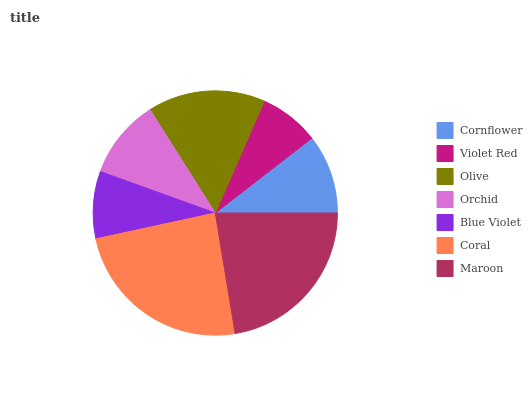Is Violet Red the minimum?
Answer yes or no. Yes. Is Coral the maximum?
Answer yes or no. Yes. Is Olive the minimum?
Answer yes or no. No. Is Olive the maximum?
Answer yes or no. No. Is Olive greater than Violet Red?
Answer yes or no. Yes. Is Violet Red less than Olive?
Answer yes or no. Yes. Is Violet Red greater than Olive?
Answer yes or no. No. Is Olive less than Violet Red?
Answer yes or no. No. Is Orchid the high median?
Answer yes or no. Yes. Is Orchid the low median?
Answer yes or no. Yes. Is Blue Violet the high median?
Answer yes or no. No. Is Cornflower the low median?
Answer yes or no. No. 